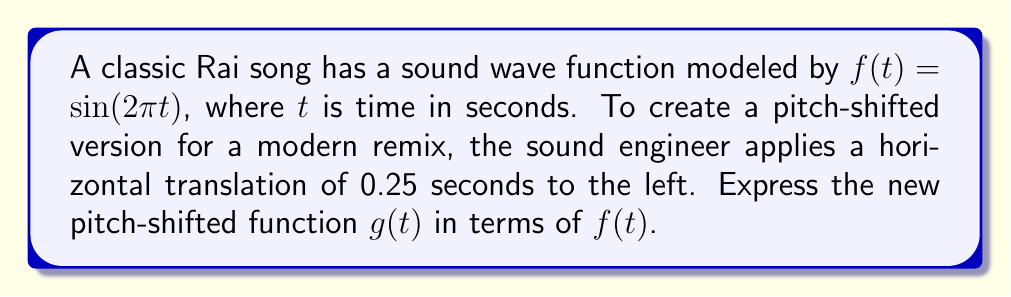Could you help me with this problem? 1) The original function is $f(t) = \sin(2\pi t)$.

2) A horizontal translation of 0.25 seconds to the left is represented by replacing $t$ with $(t + 0.25)$ in the original function.

3) Therefore, the new function $g(t)$ can be expressed as:
   $g(t) = f(t + 0.25)$

4) Substituting the original function:
   $g(t) = \sin(2\pi(t + 0.25))$

5) This can also be written as:
   $g(t) = \sin(2\pi t + \frac{\pi}{2})$

6) The pitch-shifted function $g(t)$ is thus a quarter-cycle ahead of the original function $f(t)$, resulting in a higher pitch.
Answer: $g(t) = f(t + 0.25)$ 